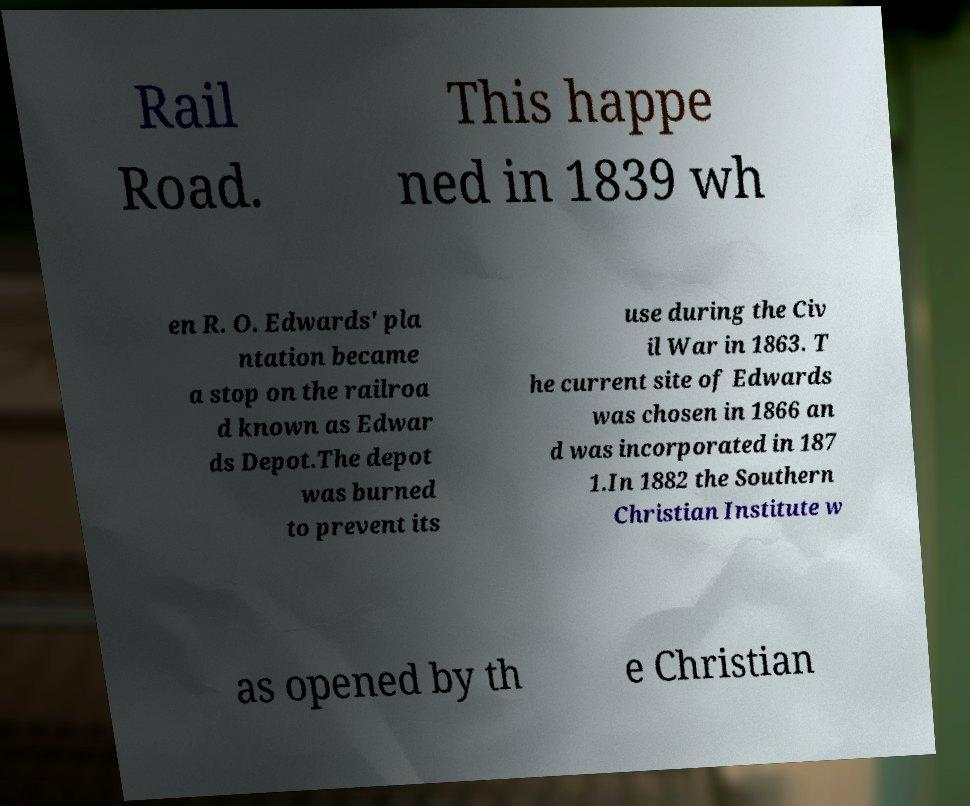Could you extract and type out the text from this image? Rail Road. This happe ned in 1839 wh en R. O. Edwards' pla ntation became a stop on the railroa d known as Edwar ds Depot.The depot was burned to prevent its use during the Civ il War in 1863. T he current site of Edwards was chosen in 1866 an d was incorporated in 187 1.In 1882 the Southern Christian Institute w as opened by th e Christian 